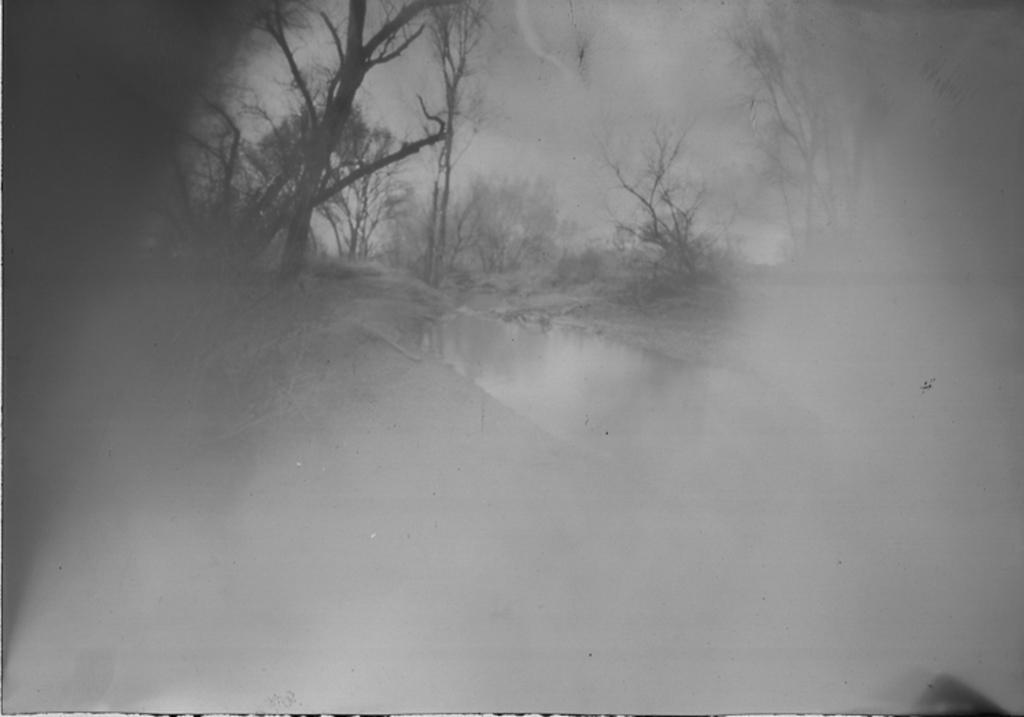What is the primary feature of the image? The primary feature of the image is the fog. What can be seen behind the fog? There is water and trees visible behind the fog. What type of quartz can be seen in the image? There is no quartz present in the image. What plant is growing in the water behind the fog? There is no plant visible in the water behind the fog in the image. 